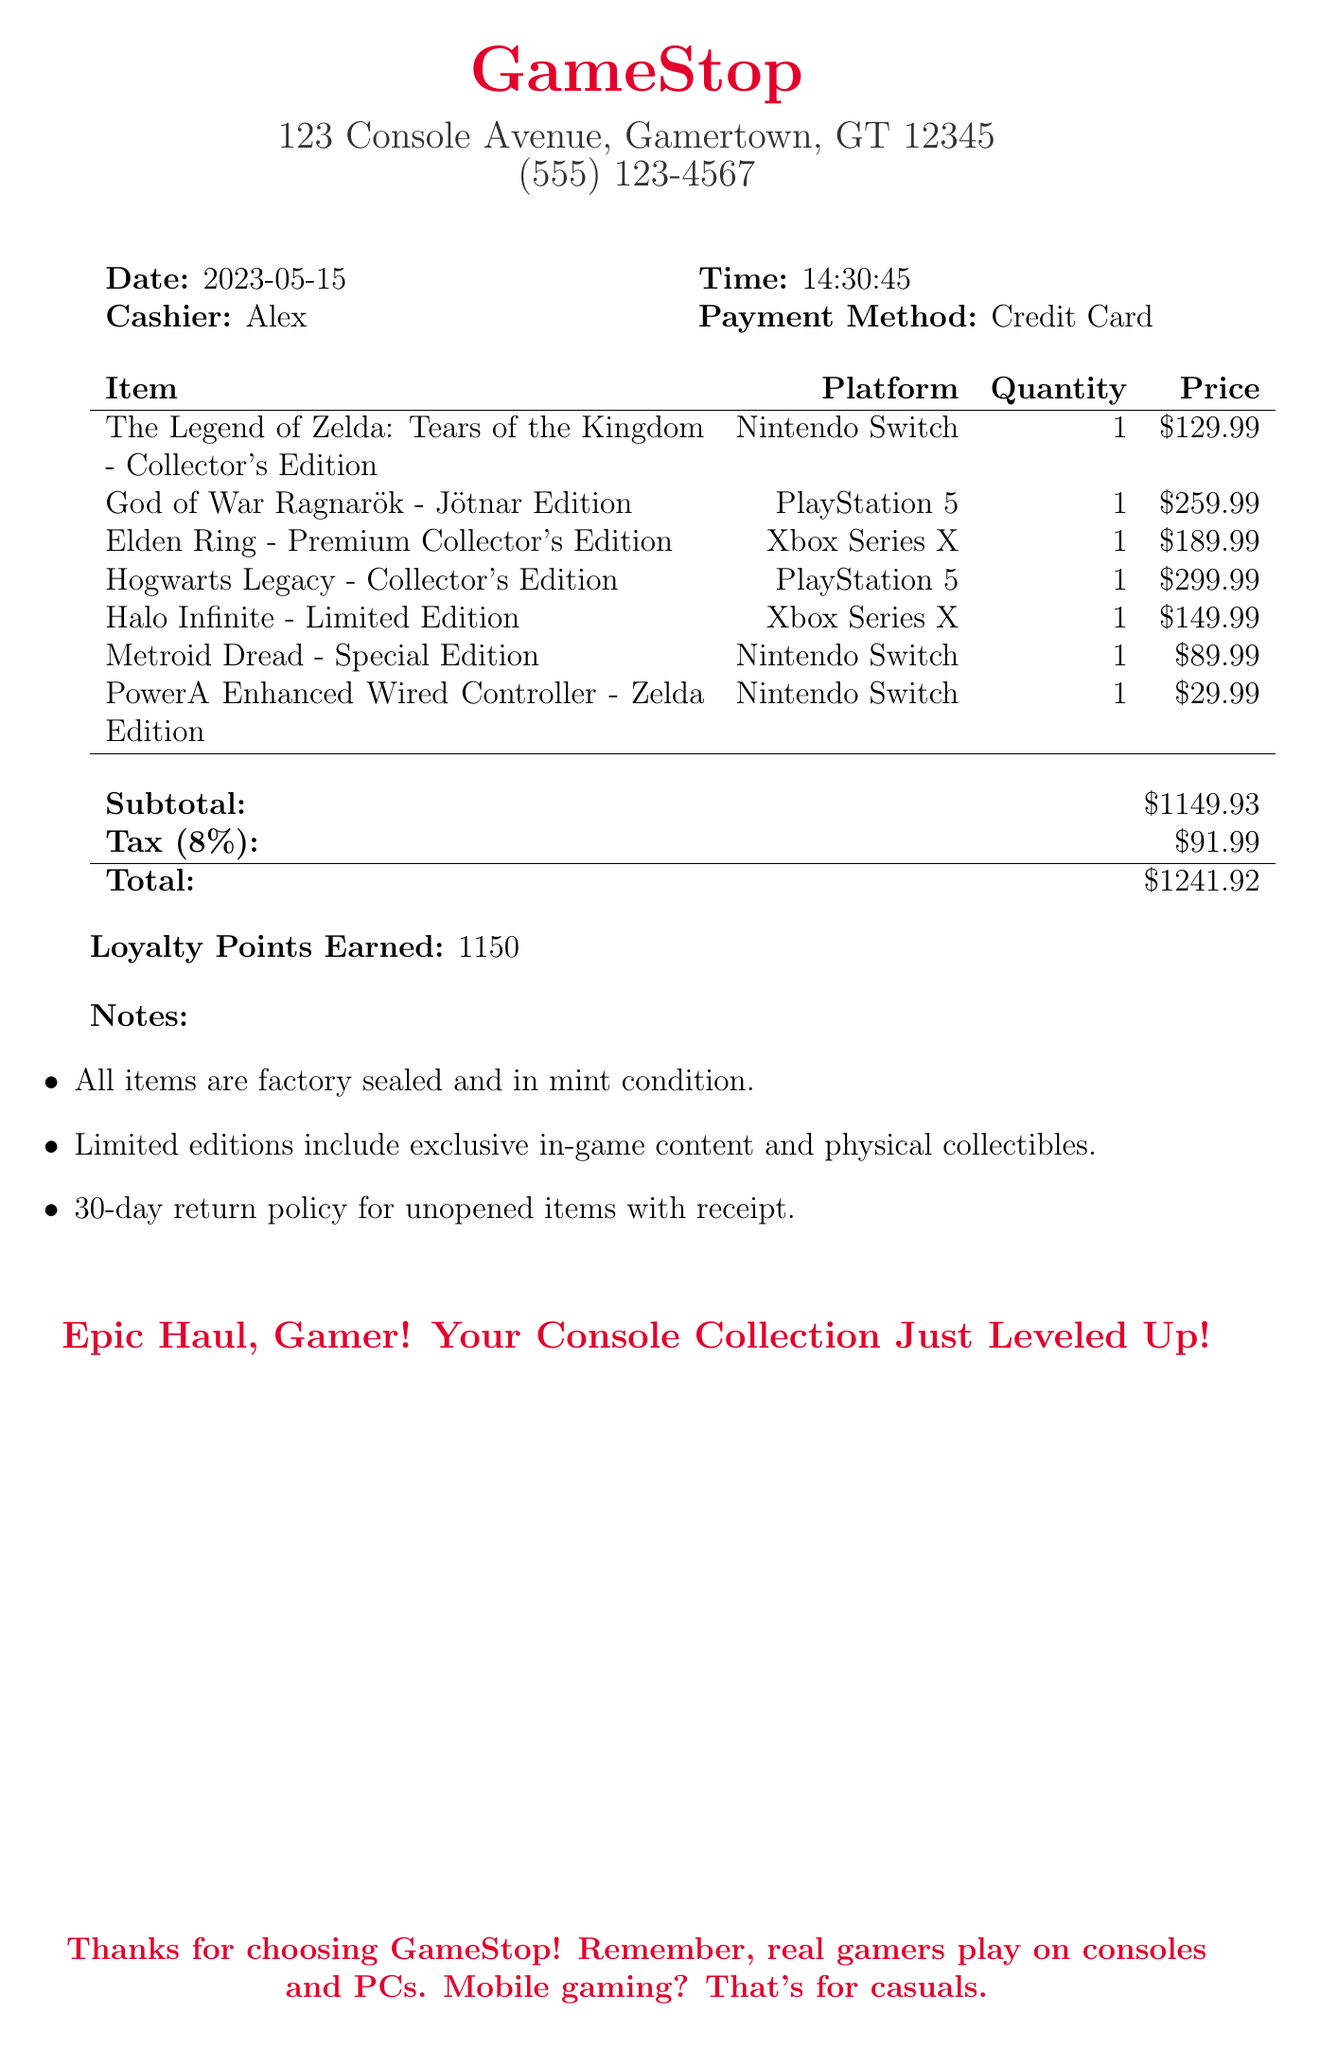What is the store name? The store name is displayed prominently at the top of the receipt.
Answer: GameStop What is the date of purchase? The date of purchase is listed in the document under the date section.
Answer: 2023-05-15 Who was the cashier? The cashier's name is mentioned in the cashier section.
Answer: Alex What is the total amount spent? The total amount is located in the summary section of the receipt.
Answer: 1241.92 How many loyalty points were earned? The loyalty points earned are mentioned towards the end of the receipt.
Answer: 1150 What platform is Elden Ring for? The platform for Elden Ring is listed alongside its name in the items section.
Answer: Xbox Series X How many items are listed on the receipt? The number of items can be counted from the itemized list presented.
Answer: 7 What is included in the notes? The notes section provides additional details regarding the items purchased.
Answer: Factory sealed, exclusive content, 30-day return policy 